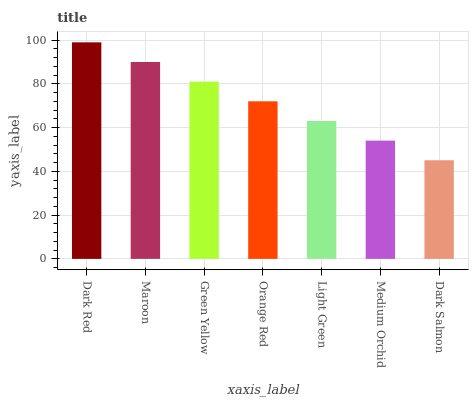Is Dark Salmon the minimum?
Answer yes or no. Yes. Is Dark Red the maximum?
Answer yes or no. Yes. Is Maroon the minimum?
Answer yes or no. No. Is Maroon the maximum?
Answer yes or no. No. Is Dark Red greater than Maroon?
Answer yes or no. Yes. Is Maroon less than Dark Red?
Answer yes or no. Yes. Is Maroon greater than Dark Red?
Answer yes or no. No. Is Dark Red less than Maroon?
Answer yes or no. No. Is Orange Red the high median?
Answer yes or no. Yes. Is Orange Red the low median?
Answer yes or no. Yes. Is Light Green the high median?
Answer yes or no. No. Is Dark Salmon the low median?
Answer yes or no. No. 